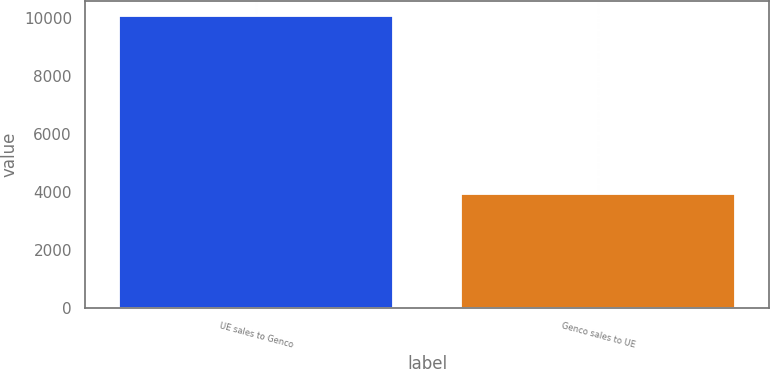Convert chart. <chart><loc_0><loc_0><loc_500><loc_500><bar_chart><fcel>UE sales to Genco<fcel>Genco sales to UE<nl><fcel>10072<fcel>3917<nl></chart> 